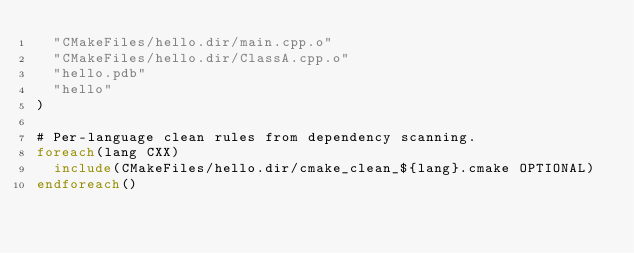<code> <loc_0><loc_0><loc_500><loc_500><_CMake_>  "CMakeFiles/hello.dir/main.cpp.o"
  "CMakeFiles/hello.dir/ClassA.cpp.o"
  "hello.pdb"
  "hello"
)

# Per-language clean rules from dependency scanning.
foreach(lang CXX)
  include(CMakeFiles/hello.dir/cmake_clean_${lang}.cmake OPTIONAL)
endforeach()
</code> 